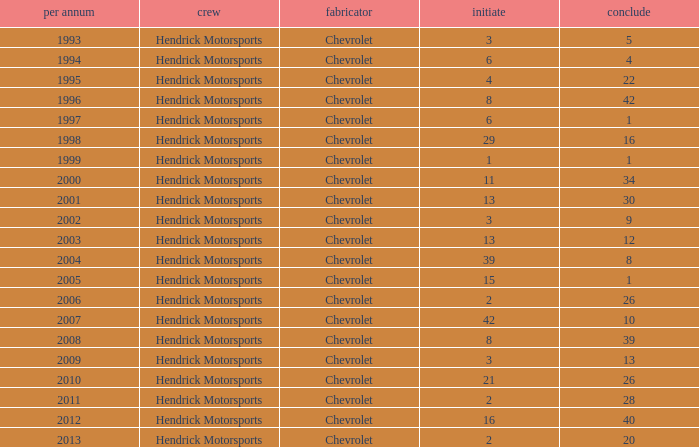Would you mind parsing the complete table? {'header': ['per annum', 'crew', 'fabricator', 'initiate', 'conclude'], 'rows': [['1993', 'Hendrick Motorsports', 'Chevrolet', '3', '5'], ['1994', 'Hendrick Motorsports', 'Chevrolet', '6', '4'], ['1995', 'Hendrick Motorsports', 'Chevrolet', '4', '22'], ['1996', 'Hendrick Motorsports', 'Chevrolet', '8', '42'], ['1997', 'Hendrick Motorsports', 'Chevrolet', '6', '1'], ['1998', 'Hendrick Motorsports', 'Chevrolet', '29', '16'], ['1999', 'Hendrick Motorsports', 'Chevrolet', '1', '1'], ['2000', 'Hendrick Motorsports', 'Chevrolet', '11', '34'], ['2001', 'Hendrick Motorsports', 'Chevrolet', '13', '30'], ['2002', 'Hendrick Motorsports', 'Chevrolet', '3', '9'], ['2003', 'Hendrick Motorsports', 'Chevrolet', '13', '12'], ['2004', 'Hendrick Motorsports', 'Chevrolet', '39', '8'], ['2005', 'Hendrick Motorsports', 'Chevrolet', '15', '1'], ['2006', 'Hendrick Motorsports', 'Chevrolet', '2', '26'], ['2007', 'Hendrick Motorsports', 'Chevrolet', '42', '10'], ['2008', 'Hendrick Motorsports', 'Chevrolet', '8', '39'], ['2009', 'Hendrick Motorsports', 'Chevrolet', '3', '13'], ['2010', 'Hendrick Motorsports', 'Chevrolet', '21', '26'], ['2011', 'Hendrick Motorsports', 'Chevrolet', '2', '28'], ['2012', 'Hendrick Motorsports', 'Chevrolet', '16', '40'], ['2013', 'Hendrick Motorsports', 'Chevrolet', '2', '20']]} What was Jeff's finish in 2011? 28.0. 